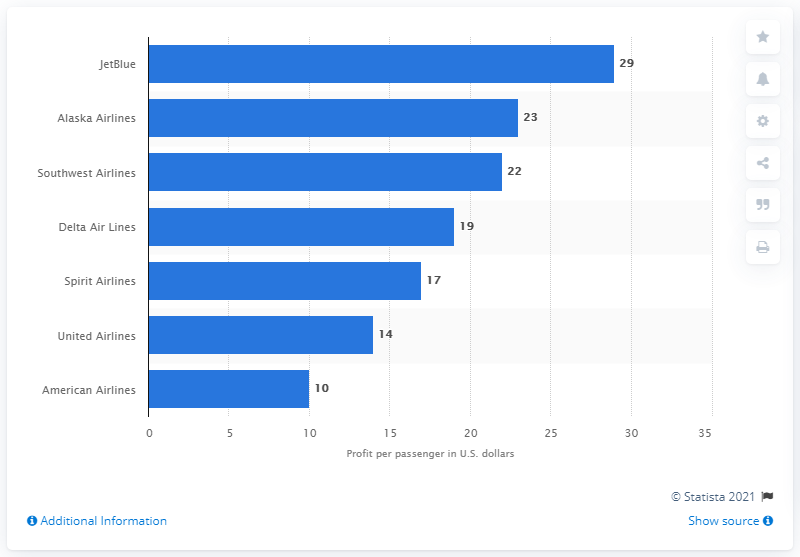Indicate a few pertinent items in this graphic. In 2017, Southwest Airlines reported a profit per passenger of $22. 